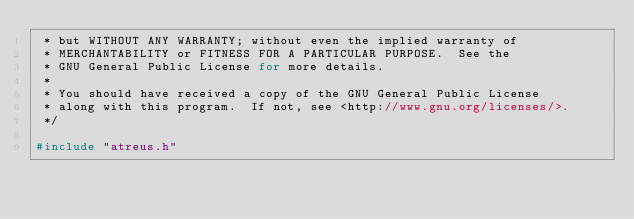Convert code to text. <code><loc_0><loc_0><loc_500><loc_500><_C_> * but WITHOUT ANY WARRANTY; without even the implied warranty of
 * MERCHANTABILITY or FITNESS FOR A PARTICULAR PURPOSE.  See the
 * GNU General Public License for more details.
 *
 * You should have received a copy of the GNU General Public License
 * along with this program.  If not, see <http://www.gnu.org/licenses/>.
 */

#include "atreus.h"
</code> 